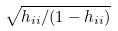Convert formula to latex. <formula><loc_0><loc_0><loc_500><loc_500>\sqrt { h _ { i i } / ( 1 - h _ { i i } ) }</formula> 